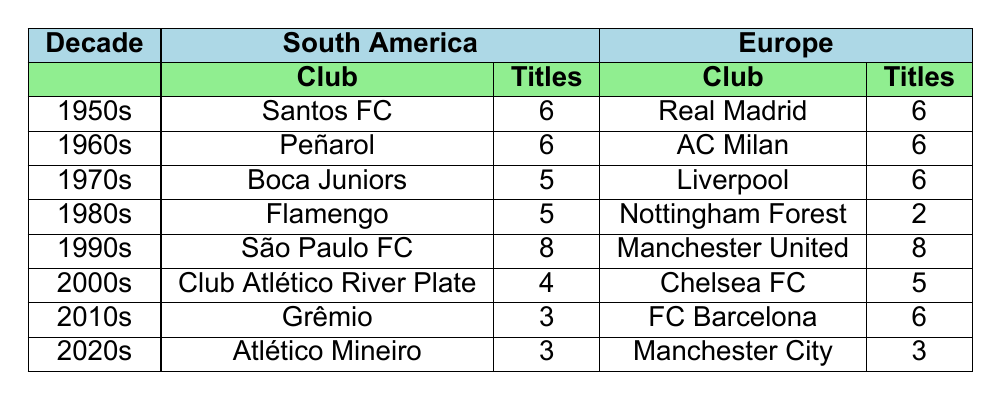What club had the highest number of titles in the 1990s? The club with the highest number of titles in the 1990s is São Paulo FC with 8 titles, as indicated in the table under the 1990s row in the South America section.
Answer: São Paulo FC How many titles did AC Milan win compared to Liverpool in the 1970s? AC Milan won 6 titles in the 1960s, while Liverpool won 6 titles in the 1970s. Therefore, both clubs have the same number of titles in this time frame, which is evidenced by looking at the respective rows for AC Milan and Liverpool.
Answer: They both won 6 titles Which region had more clubs winning titles in the 1980s, South America or Europe? In the 1980s, South America had one club, Flamengo, winning 5 titles. In contrast, Europe had one club, Nottingham Forest, winning 2 titles. Since only one club from each region is represented, South America had more titles in that decade.
Answer: South America had more Did Atlético Mineiro win more titles than Chelsea FC in the 2000s? Atlético Mineiro won 3 titles in the 2020s, whereas Chelsea FC won 5 titles in the 2000s. Losing track of the decades would lead to confusion, but by comparing the correct years, it's clear Chelsea FC had more titles.
Answer: No, Chelsea FC had more What is the total number of titles won by clubs in South America in the 1990s and 2000s combined? In the 1990s, São Paulo FC won 8 titles, and in the 2000s, Club Atlético River Plate won 4 titles. Adding these gives 8 + 4 = 12 titles combined for both decades in South America.
Answer: 12 titles Which club had the fewest titles in the table and what decade did they play in? Nottingham Forest had the fewest titles with 2, which they won in the 1980s, as indicated by their respective entry in the table.
Answer: Nottingham Forest, 1980s Is the number of titles won by clubs in the 2010s greater than that in the 2020s? In the 2010s, Grêmio won 3 titles, while in the 2020s, Atlético Mineiro and Manchester City both won 3 titles each, making the total for the 2020s also 3. Thus, the number of titles is equal, confirming that the comparison is accurate.
Answer: No, they are equal How many total titles did European clubs win from the 1950s to the 2010s? Summing the titles from the table for European clubs: 6 (Real Madrid) + 6 (AC Milan) + 6 (Liverpool) + 2 (Nottingham Forest) + 8 (Manchester United) + 5 (Chelsea FC) + 6 (FC Barcelona) equals a total of 39 titles over these decades.
Answer: 39 titles Which South American club had the most titles in the table? São Paulo FC had the most titles with 8 in the 1990s, as seen in the South American part for that decade, confirming their dominance in that time period.
Answer: São Paulo FC 